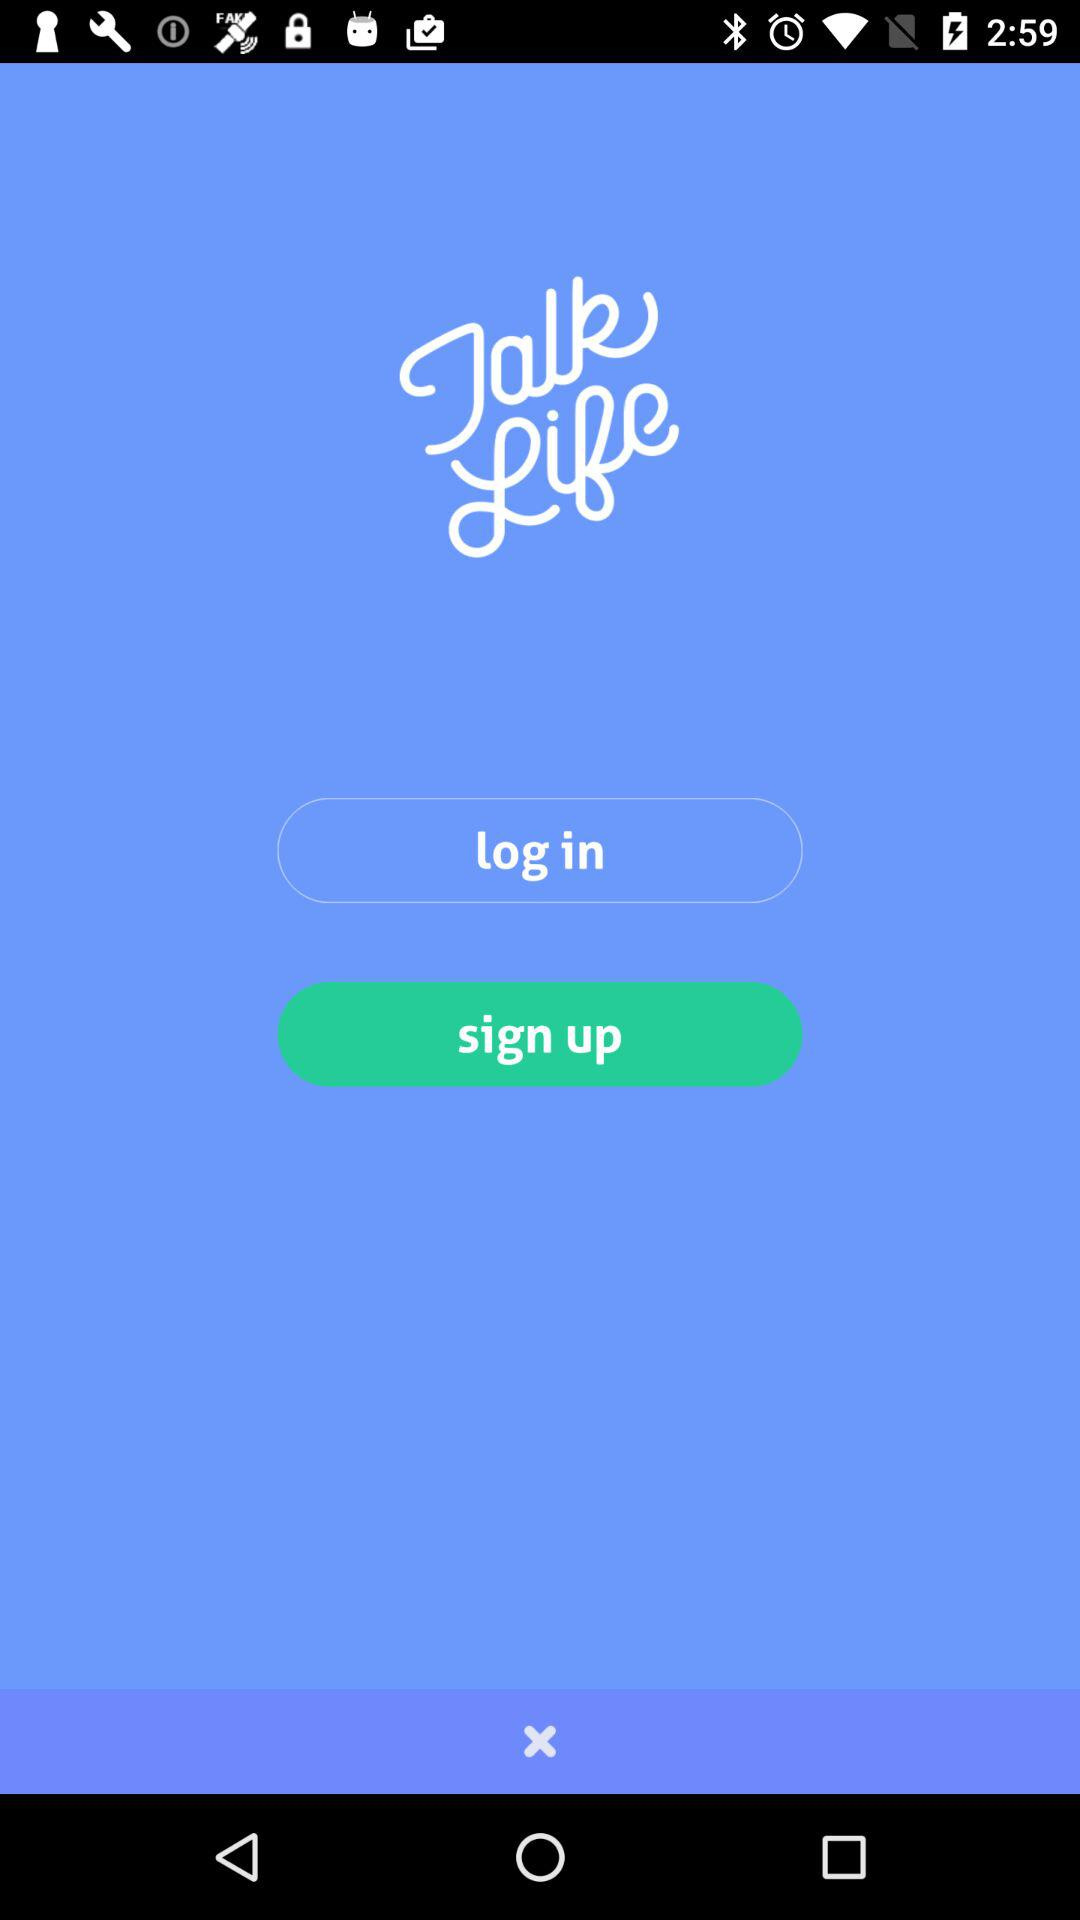What is the application name? The application name is "Talk Life". 